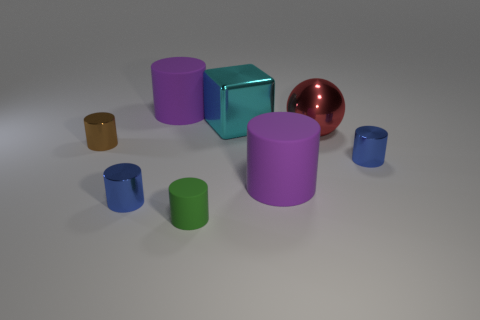Subtract all brown cylinders. How many cylinders are left? 5 Subtract 2 cylinders. How many cylinders are left? 4 Subtract all purple cylinders. How many cylinders are left? 4 Subtract all gray cylinders. Subtract all brown blocks. How many cylinders are left? 6 Subtract all cylinders. How many objects are left? 2 Add 1 blue metal things. How many objects exist? 9 Subtract all small brown rubber spheres. Subtract all cylinders. How many objects are left? 2 Add 5 large objects. How many large objects are left? 9 Add 7 cyan metal blocks. How many cyan metal blocks exist? 8 Subtract 0 purple balls. How many objects are left? 8 